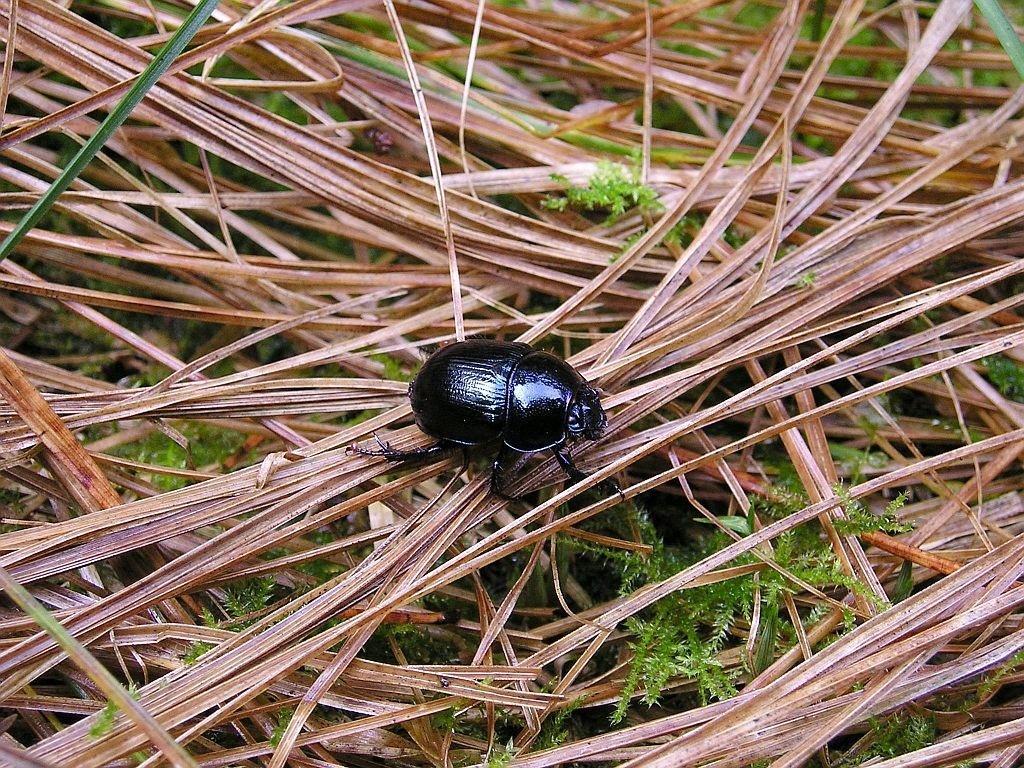Please provide a concise description of this image. In the picture i can see an insect which is in black color and we can see some leaves which are in brown and green color. 